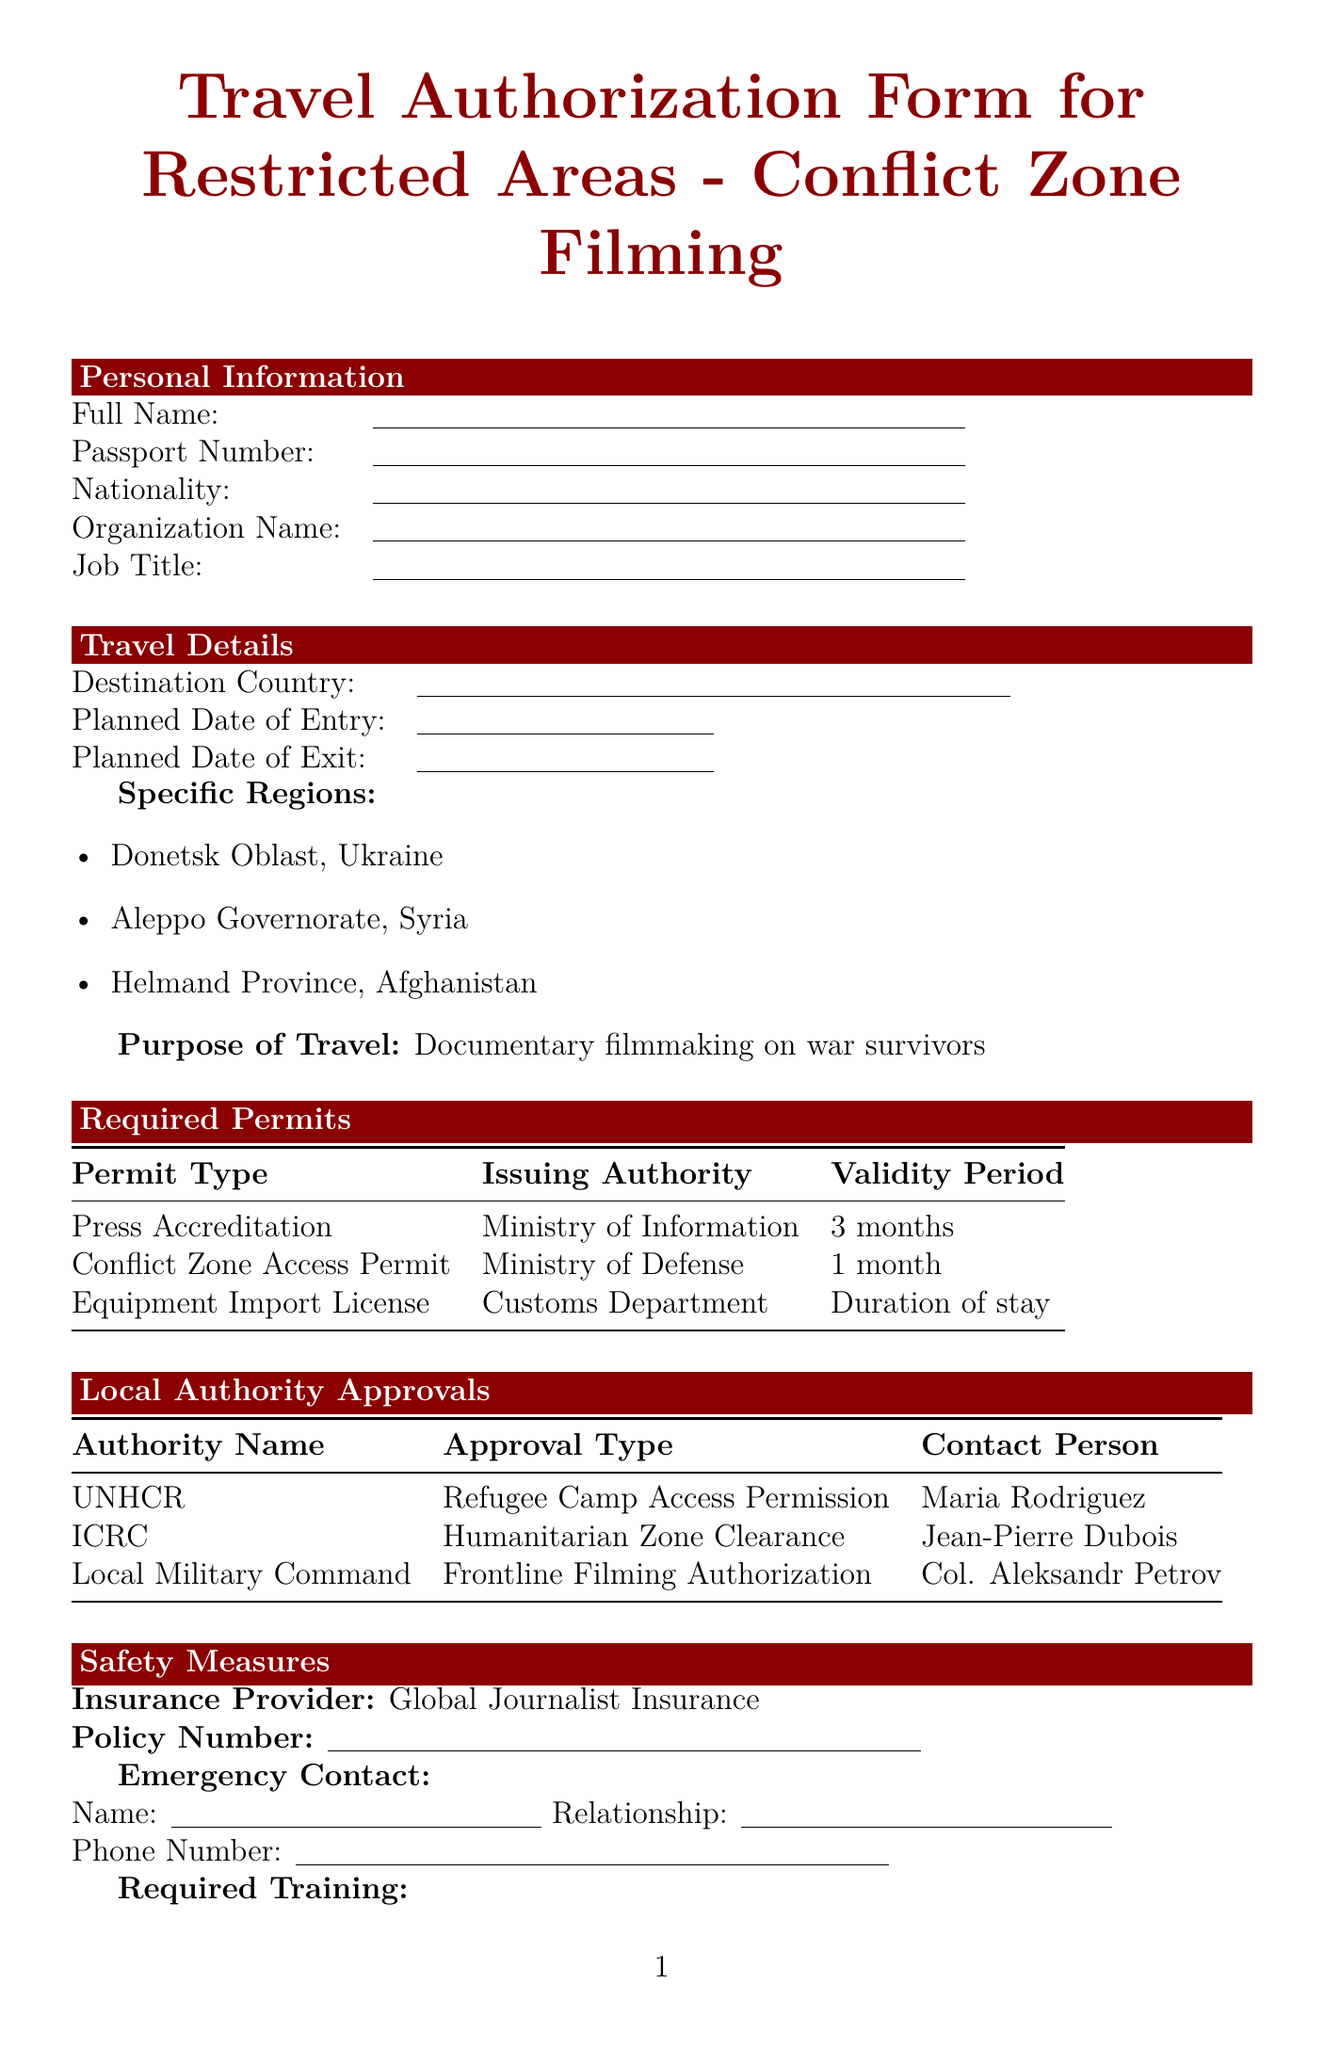what is the purpose of travel? The purpose of travel is stated clearly in the document as "Documentary filmmaking on war survivors."
Answer: Documentary filmmaking on war survivors which region is listed as a specific location for travel? A specific region for travel mentioned in the document is "Donetsk Oblast, Ukraine."
Answer: Donetsk Oblast, Ukraine what is the validity period of the Conflict Zone Access Permit? The validity period for the Conflict Zone Access Permit is explicitly noted in the document as "1 month."
Answer: 1 month who is the contact person for the UNHCR? The document specifies that the contact person for the UNHCR is "Maria Rodriguez."
Answer: Maria Rodriguez which organization issues the Equipment Import License? The Equipment Import License is issued by the "Customs Department" according to the document.
Answer: Customs Department what type of training is required regarding hostile environments? The document mentions that "Hostile Environment Awareness Training (HEAT)" is required.
Answer: Hostile Environment Awareness Training (HEAT) what is the insurance provider listed in the safety measures? The insurance provider stated in the safety measures is "Global Journalist Insurance."
Answer: Global Journalist Insurance how many specific regions are listed for restricted areas? The document lists three specific regions for restricted areas, which is the total number of regions mentioned.
Answer: 3 